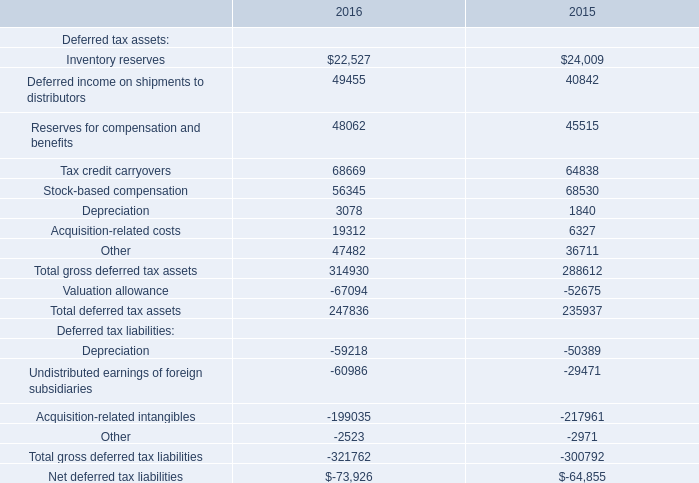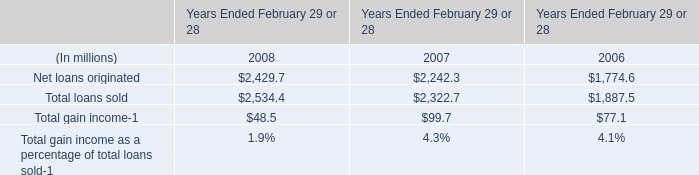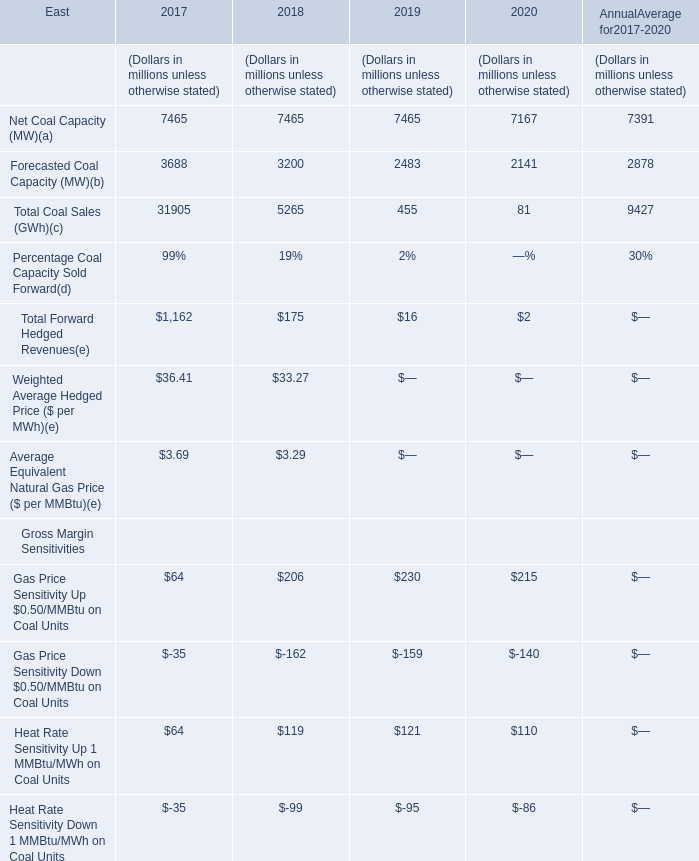What's the sum of all Gross Margin Sensitivities that are positive in 2019? (in million) 
Computations: (230 + 121)
Answer: 351.0. 